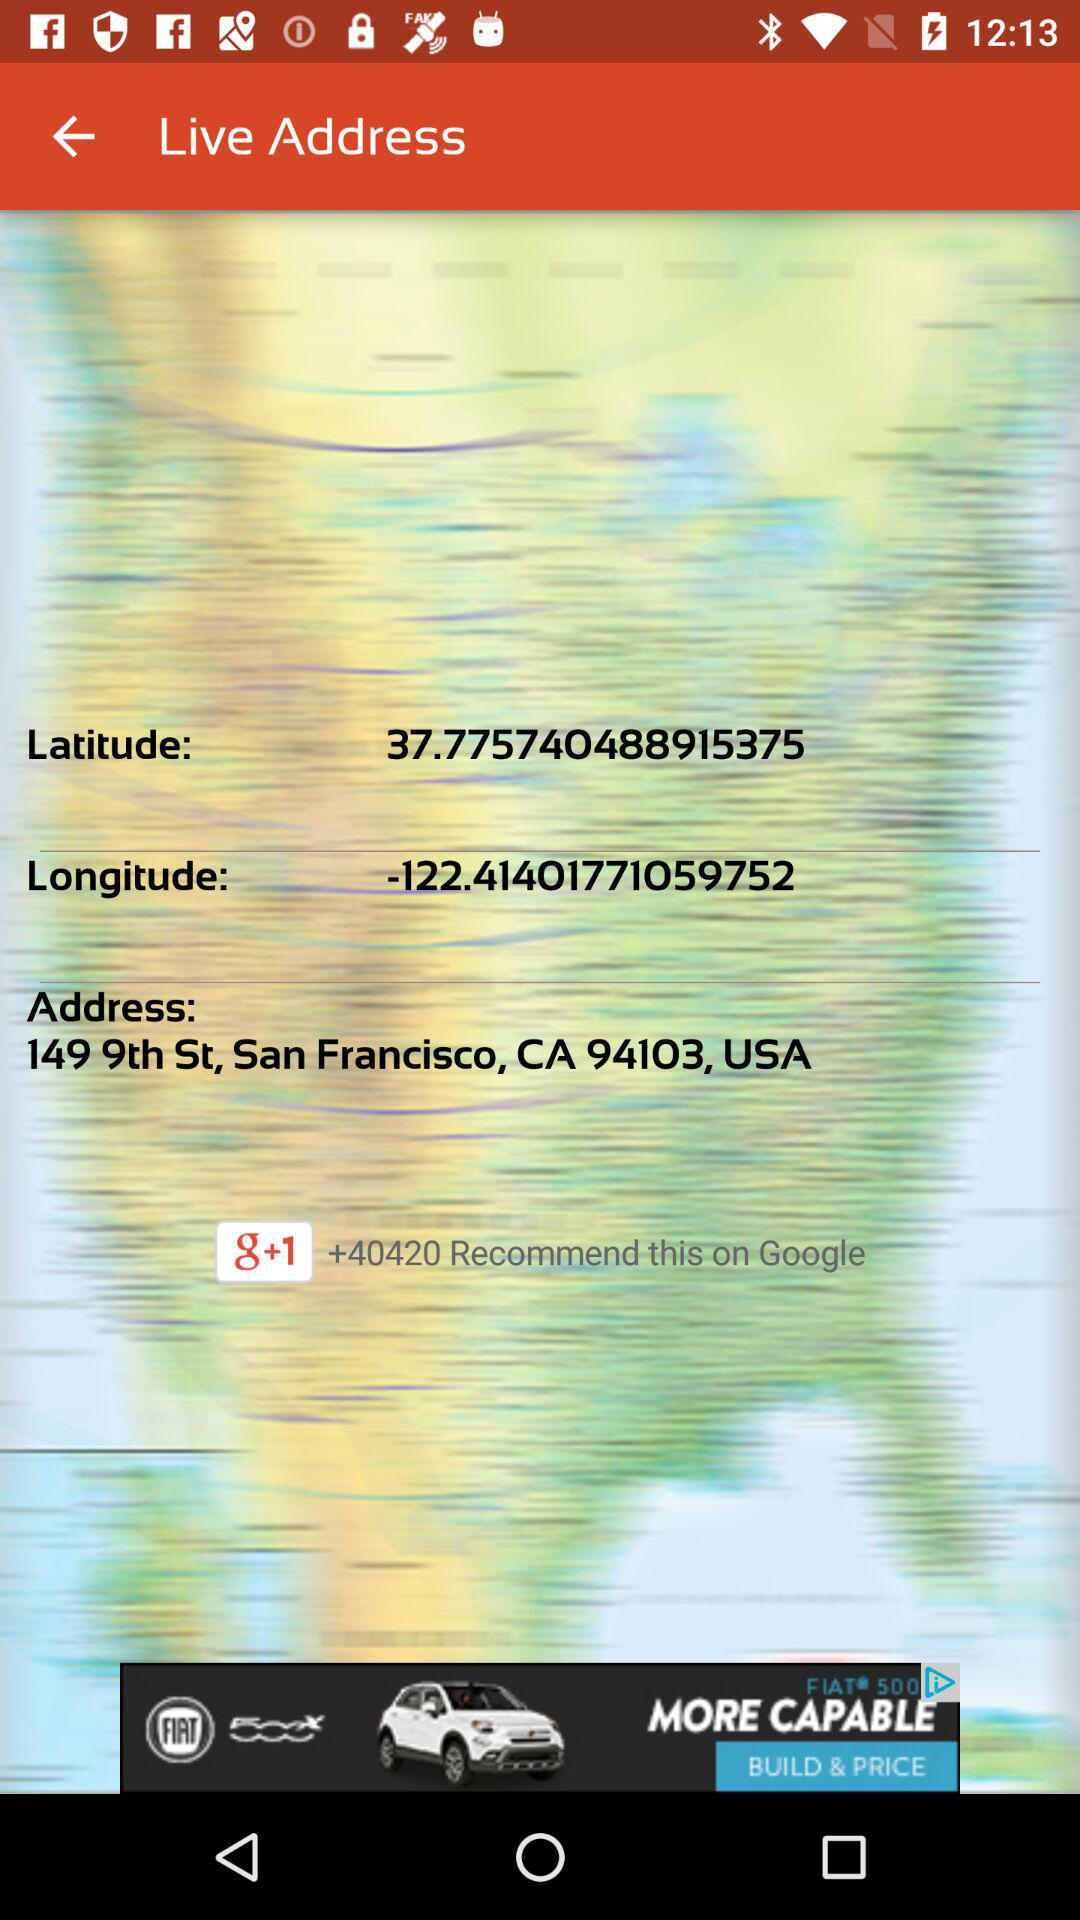How far away is the location?
When the provided information is insufficient, respond with <no answer>. <no answer> 